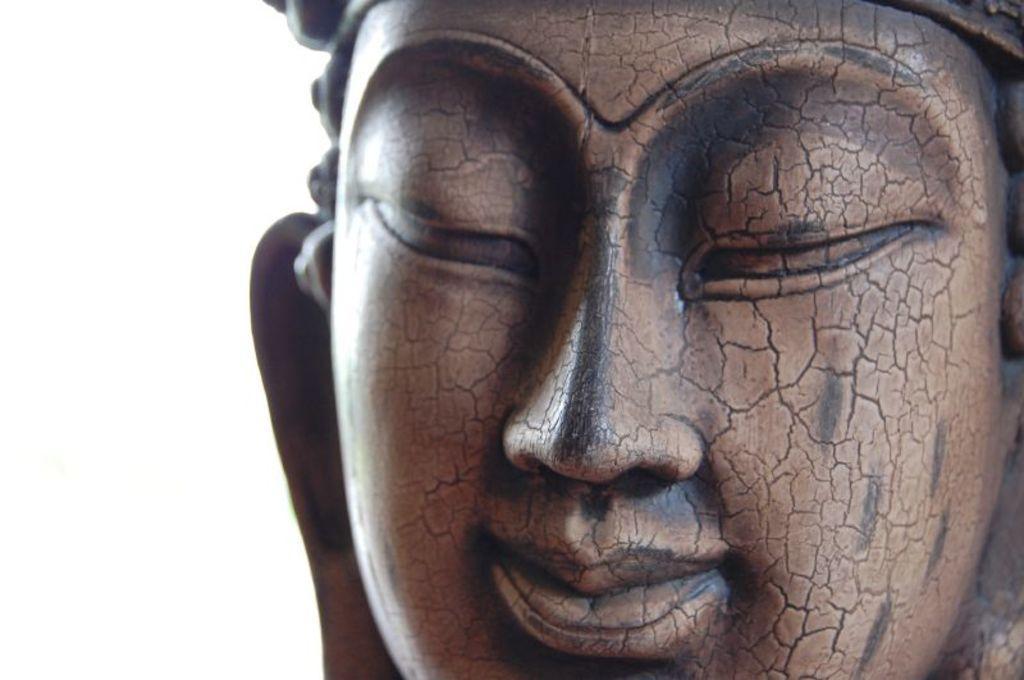Can you describe this image briefly? In this picture there is a sculpture. On the left side of the image there is a white background. 